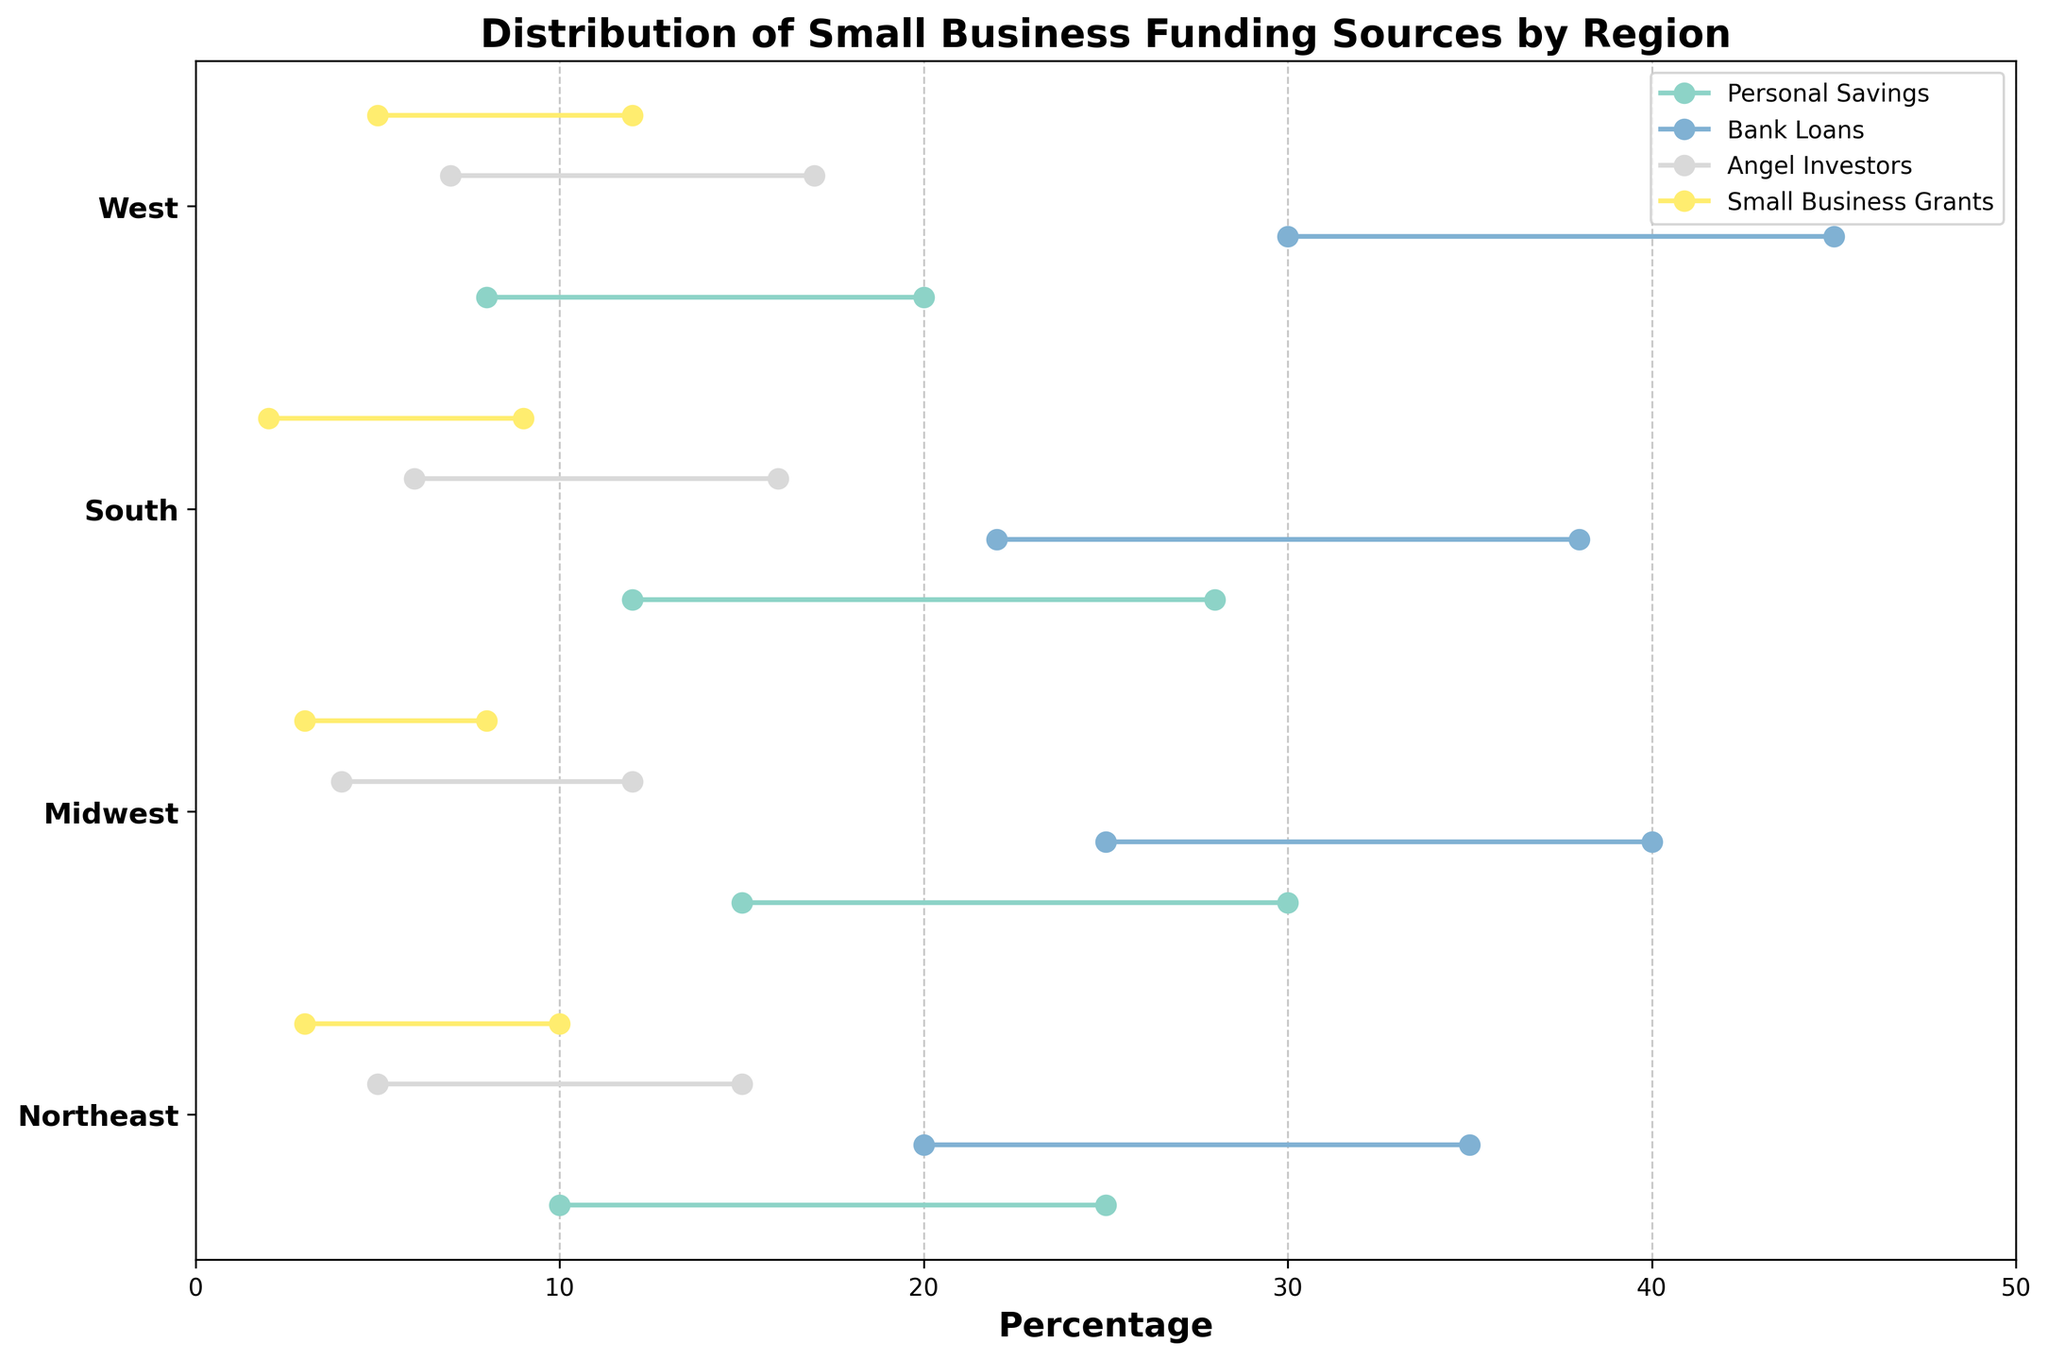What is the title of the figure? The title is located at the top of the figure and provides the main description of what the plot is visualizing.
Answer: Distribution of Small Business Funding Sources by Region Which funding source has the widest range in the Northeast region? To find the widest range, look at the difference between the min and max percentages for each funding source in the Northeast. Calculate the difference for Personal Savings (25-10=15), Bank Loans (35-20=15), Angel Investors (15-5=10), and Small Business Grants (10-3=7). The largest range is a tie between Personal Savings and Bank Loans both with a range of 15.
Answer: Personal Savings and Bank Loans What is the minimum percentage of personal savings in the West region? Identify the West region and find the dot that corresponds to the minimum percentage of Personal Savings within that region.
Answer: 8% In which region do Bank Loans have the highest minimum percentage? Compare the minimum percentages for Bank Loans across all regions: Northeast (20), Midwest (25), South (22), and West (30). The highest minimum value is in the West.
Answer: West Which funding source has the smallest minimum percentage in the Midwest? Look at the minimum percentage values for all funding sources in the Midwest: Personal Savings (15), Bank Loans (25), Angel Investors (4), and Small Business Grants (3). The smallest minimum value is 3 for Small Business Grants.
Answer: Small Business Grants What is the difference between the maximum and minimum percentages of Angel Investors in the South? Find the minimum and maximum percentages for Angel Investors in the South region: min is 6 and max is 16. Calculate the difference: 16 - 6 = 10.
Answer: 10 How does the range for Small Business Grants in the South compare to that in the West? Calculate the range for Small Business Grants in both regions: South (9-2=7), West (12-5=7). Both regions have the same range of 7.
Answer: Equal Which region has the highest maximum percentage for any funding source and what is that source? Identify the highest maximum percentage across all regions and funding sources. The highest is 45% for Bank Loans in the West.
Answer: West, Bank Loans 